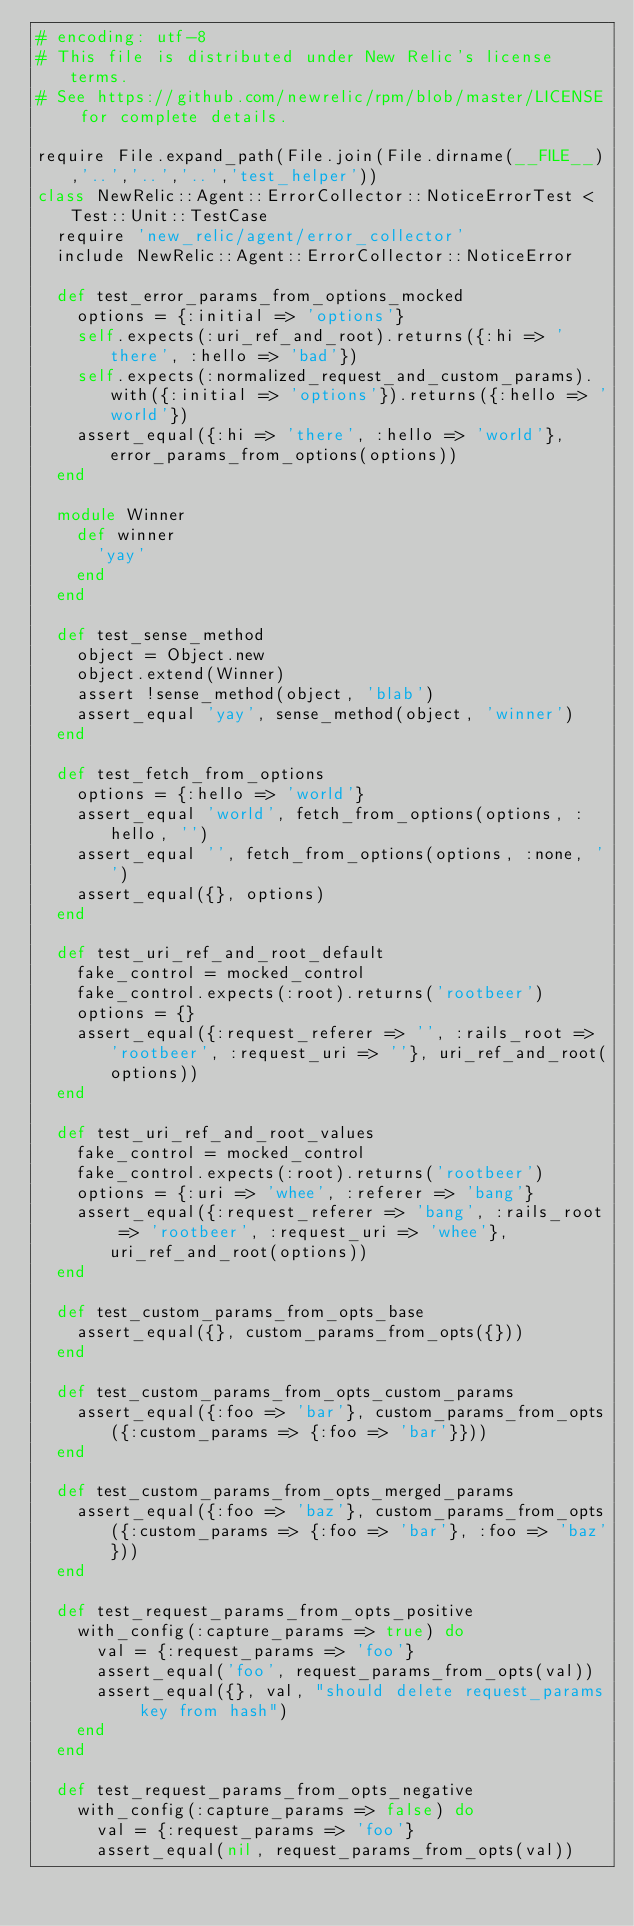<code> <loc_0><loc_0><loc_500><loc_500><_Ruby_># encoding: utf-8
# This file is distributed under New Relic's license terms.
# See https://github.com/newrelic/rpm/blob/master/LICENSE for complete details.

require File.expand_path(File.join(File.dirname(__FILE__),'..','..','..','test_helper'))
class NewRelic::Agent::ErrorCollector::NoticeErrorTest < Test::Unit::TestCase
  require 'new_relic/agent/error_collector'
  include NewRelic::Agent::ErrorCollector::NoticeError

  def test_error_params_from_options_mocked
    options = {:initial => 'options'}
    self.expects(:uri_ref_and_root).returns({:hi => 'there', :hello => 'bad'})
    self.expects(:normalized_request_and_custom_params).with({:initial => 'options'}).returns({:hello => 'world'})
    assert_equal({:hi => 'there', :hello => 'world'}, error_params_from_options(options))
  end

  module Winner
    def winner
      'yay'
    end
  end

  def test_sense_method
    object = Object.new
    object.extend(Winner)
    assert !sense_method(object, 'blab')
    assert_equal 'yay', sense_method(object, 'winner')
  end

  def test_fetch_from_options
    options = {:hello => 'world'}
    assert_equal 'world', fetch_from_options(options, :hello, '')
    assert_equal '', fetch_from_options(options, :none, '')
    assert_equal({}, options)
  end

  def test_uri_ref_and_root_default
    fake_control = mocked_control
    fake_control.expects(:root).returns('rootbeer')
    options = {}
    assert_equal({:request_referer => '', :rails_root => 'rootbeer', :request_uri => ''}, uri_ref_and_root(options))
  end

  def test_uri_ref_and_root_values
    fake_control = mocked_control
    fake_control.expects(:root).returns('rootbeer')
    options = {:uri => 'whee', :referer => 'bang'}
    assert_equal({:request_referer => 'bang', :rails_root => 'rootbeer', :request_uri => 'whee'}, uri_ref_and_root(options))
  end

  def test_custom_params_from_opts_base
    assert_equal({}, custom_params_from_opts({}))
  end

  def test_custom_params_from_opts_custom_params
    assert_equal({:foo => 'bar'}, custom_params_from_opts({:custom_params => {:foo => 'bar'}}))
  end

  def test_custom_params_from_opts_merged_params
    assert_equal({:foo => 'baz'}, custom_params_from_opts({:custom_params => {:foo => 'bar'}, :foo => 'baz'}))
  end

  def test_request_params_from_opts_positive
    with_config(:capture_params => true) do
      val = {:request_params => 'foo'}
      assert_equal('foo', request_params_from_opts(val))
      assert_equal({}, val, "should delete request_params key from hash")
    end
  end

  def test_request_params_from_opts_negative
    with_config(:capture_params => false) do
      val = {:request_params => 'foo'}
      assert_equal(nil, request_params_from_opts(val))</code> 